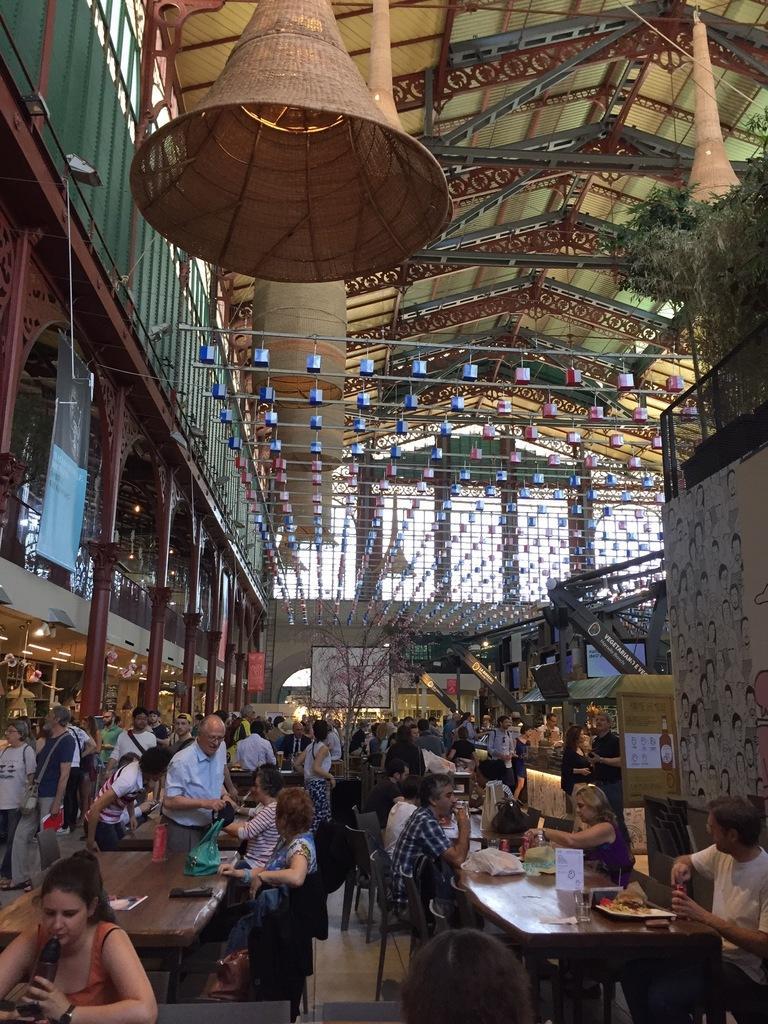Can you describe this image briefly? In this image there are group of persons standing and sitting. On the top there are lights hanging. On the left side there are pillars. On the right side there are objects which are grey in colour and there is a wall and on the top of the wall there are plants. 